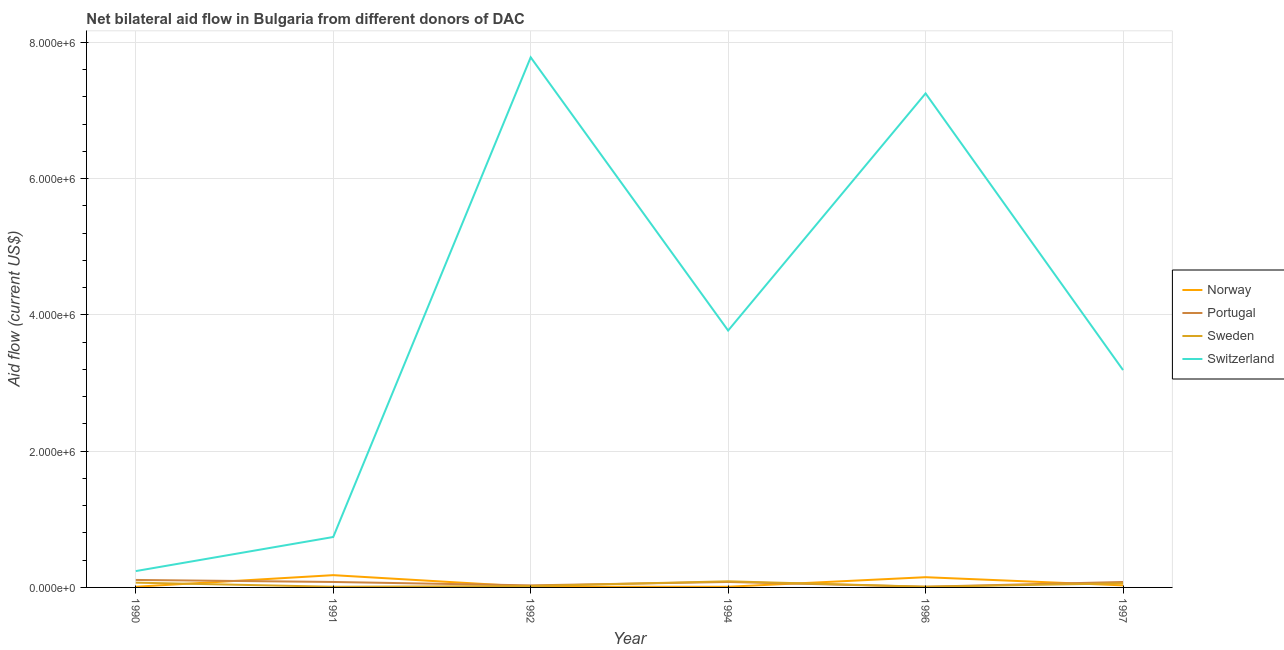Is the number of lines equal to the number of legend labels?
Offer a terse response. Yes. What is the amount of aid given by sweden in 1991?
Ensure brevity in your answer.  10000. Across all years, what is the maximum amount of aid given by sweden?
Provide a short and direct response. 9.00e+04. Across all years, what is the minimum amount of aid given by portugal?
Ensure brevity in your answer.  10000. In which year was the amount of aid given by switzerland maximum?
Give a very brief answer. 1992. What is the total amount of aid given by switzerland in the graph?
Provide a short and direct response. 2.30e+07. What is the difference between the amount of aid given by norway in 1991 and that in 1997?
Your answer should be very brief. 1.50e+05. What is the difference between the amount of aid given by switzerland in 1997 and the amount of aid given by norway in 1996?
Offer a very short reply. 3.04e+06. What is the average amount of aid given by sweden per year?
Your answer should be compact. 4.33e+04. In the year 1990, what is the difference between the amount of aid given by switzerland and amount of aid given by norway?
Your answer should be compact. 2.30e+05. Is the amount of aid given by switzerland in 1990 less than that in 1997?
Make the answer very short. Yes. What is the difference between the highest and the second highest amount of aid given by sweden?
Give a very brief answer. 2.00e+04. What is the difference between the highest and the lowest amount of aid given by norway?
Your response must be concise. 1.70e+05. In how many years, is the amount of aid given by norway greater than the average amount of aid given by norway taken over all years?
Offer a terse response. 2. Is the sum of the amount of aid given by switzerland in 1994 and 1996 greater than the maximum amount of aid given by sweden across all years?
Provide a succinct answer. Yes. Is it the case that in every year, the sum of the amount of aid given by switzerland and amount of aid given by portugal is greater than the sum of amount of aid given by sweden and amount of aid given by norway?
Provide a short and direct response. Yes. Does the amount of aid given by portugal monotonically increase over the years?
Make the answer very short. No. How many lines are there?
Give a very brief answer. 4. How many years are there in the graph?
Make the answer very short. 6. Are the values on the major ticks of Y-axis written in scientific E-notation?
Your answer should be compact. Yes. Where does the legend appear in the graph?
Keep it short and to the point. Center right. What is the title of the graph?
Offer a very short reply. Net bilateral aid flow in Bulgaria from different donors of DAC. Does "Quality of logistic services" appear as one of the legend labels in the graph?
Provide a short and direct response. No. What is the Aid flow (current US$) in Norway in 1990?
Give a very brief answer. 10000. What is the Aid flow (current US$) in Portugal in 1991?
Your response must be concise. 8.00e+04. What is the Aid flow (current US$) of Sweden in 1991?
Offer a terse response. 10000. What is the Aid flow (current US$) of Switzerland in 1991?
Your answer should be compact. 7.40e+05. What is the Aid flow (current US$) of Portugal in 1992?
Provide a short and direct response. 3.00e+04. What is the Aid flow (current US$) of Sweden in 1992?
Offer a very short reply. 2.00e+04. What is the Aid flow (current US$) in Switzerland in 1992?
Give a very brief answer. 7.78e+06. What is the Aid flow (current US$) in Portugal in 1994?
Offer a terse response. 8.00e+04. What is the Aid flow (current US$) of Switzerland in 1994?
Give a very brief answer. 3.77e+06. What is the Aid flow (current US$) of Norway in 1996?
Offer a terse response. 1.50e+05. What is the Aid flow (current US$) of Switzerland in 1996?
Your response must be concise. 7.25e+06. What is the Aid flow (current US$) in Sweden in 1997?
Provide a short and direct response. 6.00e+04. What is the Aid flow (current US$) of Switzerland in 1997?
Offer a terse response. 3.19e+06. Across all years, what is the maximum Aid flow (current US$) in Norway?
Keep it short and to the point. 1.80e+05. Across all years, what is the maximum Aid flow (current US$) in Switzerland?
Make the answer very short. 7.78e+06. Across all years, what is the minimum Aid flow (current US$) of Norway?
Ensure brevity in your answer.  10000. Across all years, what is the minimum Aid flow (current US$) of Sweden?
Ensure brevity in your answer.  10000. Across all years, what is the minimum Aid flow (current US$) in Switzerland?
Provide a short and direct response. 2.40e+05. What is the total Aid flow (current US$) in Sweden in the graph?
Ensure brevity in your answer.  2.60e+05. What is the total Aid flow (current US$) of Switzerland in the graph?
Ensure brevity in your answer.  2.30e+07. What is the difference between the Aid flow (current US$) of Switzerland in 1990 and that in 1991?
Make the answer very short. -5.00e+05. What is the difference between the Aid flow (current US$) of Norway in 1990 and that in 1992?
Give a very brief answer. 0. What is the difference between the Aid flow (current US$) in Portugal in 1990 and that in 1992?
Provide a succinct answer. 8.00e+04. What is the difference between the Aid flow (current US$) of Switzerland in 1990 and that in 1992?
Make the answer very short. -7.54e+06. What is the difference between the Aid flow (current US$) in Norway in 1990 and that in 1994?
Provide a succinct answer. 0. What is the difference between the Aid flow (current US$) of Sweden in 1990 and that in 1994?
Keep it short and to the point. -2.00e+04. What is the difference between the Aid flow (current US$) in Switzerland in 1990 and that in 1994?
Provide a succinct answer. -3.53e+06. What is the difference between the Aid flow (current US$) in Norway in 1990 and that in 1996?
Provide a short and direct response. -1.40e+05. What is the difference between the Aid flow (current US$) in Portugal in 1990 and that in 1996?
Provide a succinct answer. 1.00e+05. What is the difference between the Aid flow (current US$) of Switzerland in 1990 and that in 1996?
Keep it short and to the point. -7.01e+06. What is the difference between the Aid flow (current US$) of Switzerland in 1990 and that in 1997?
Provide a short and direct response. -2.95e+06. What is the difference between the Aid flow (current US$) of Portugal in 1991 and that in 1992?
Make the answer very short. 5.00e+04. What is the difference between the Aid flow (current US$) in Switzerland in 1991 and that in 1992?
Give a very brief answer. -7.04e+06. What is the difference between the Aid flow (current US$) in Switzerland in 1991 and that in 1994?
Offer a terse response. -3.03e+06. What is the difference between the Aid flow (current US$) in Sweden in 1991 and that in 1996?
Your answer should be compact. 0. What is the difference between the Aid flow (current US$) in Switzerland in 1991 and that in 1996?
Offer a terse response. -6.51e+06. What is the difference between the Aid flow (current US$) of Portugal in 1991 and that in 1997?
Ensure brevity in your answer.  0. What is the difference between the Aid flow (current US$) in Sweden in 1991 and that in 1997?
Provide a succinct answer. -5.00e+04. What is the difference between the Aid flow (current US$) of Switzerland in 1991 and that in 1997?
Provide a succinct answer. -2.45e+06. What is the difference between the Aid flow (current US$) in Sweden in 1992 and that in 1994?
Give a very brief answer. -7.00e+04. What is the difference between the Aid flow (current US$) in Switzerland in 1992 and that in 1994?
Give a very brief answer. 4.01e+06. What is the difference between the Aid flow (current US$) of Portugal in 1992 and that in 1996?
Your answer should be compact. 2.00e+04. What is the difference between the Aid flow (current US$) of Switzerland in 1992 and that in 1996?
Your answer should be compact. 5.30e+05. What is the difference between the Aid flow (current US$) in Norway in 1992 and that in 1997?
Provide a succinct answer. -2.00e+04. What is the difference between the Aid flow (current US$) in Switzerland in 1992 and that in 1997?
Provide a succinct answer. 4.59e+06. What is the difference between the Aid flow (current US$) of Norway in 1994 and that in 1996?
Offer a very short reply. -1.40e+05. What is the difference between the Aid flow (current US$) in Switzerland in 1994 and that in 1996?
Ensure brevity in your answer.  -3.48e+06. What is the difference between the Aid flow (current US$) in Switzerland in 1994 and that in 1997?
Your response must be concise. 5.80e+05. What is the difference between the Aid flow (current US$) in Portugal in 1996 and that in 1997?
Offer a very short reply. -7.00e+04. What is the difference between the Aid flow (current US$) in Sweden in 1996 and that in 1997?
Offer a very short reply. -5.00e+04. What is the difference between the Aid flow (current US$) of Switzerland in 1996 and that in 1997?
Offer a terse response. 4.06e+06. What is the difference between the Aid flow (current US$) of Norway in 1990 and the Aid flow (current US$) of Switzerland in 1991?
Your response must be concise. -7.30e+05. What is the difference between the Aid flow (current US$) of Portugal in 1990 and the Aid flow (current US$) of Sweden in 1991?
Your response must be concise. 1.00e+05. What is the difference between the Aid flow (current US$) in Portugal in 1990 and the Aid flow (current US$) in Switzerland in 1991?
Provide a succinct answer. -6.30e+05. What is the difference between the Aid flow (current US$) in Sweden in 1990 and the Aid flow (current US$) in Switzerland in 1991?
Ensure brevity in your answer.  -6.70e+05. What is the difference between the Aid flow (current US$) in Norway in 1990 and the Aid flow (current US$) in Sweden in 1992?
Provide a succinct answer. -10000. What is the difference between the Aid flow (current US$) in Norway in 1990 and the Aid flow (current US$) in Switzerland in 1992?
Give a very brief answer. -7.77e+06. What is the difference between the Aid flow (current US$) in Portugal in 1990 and the Aid flow (current US$) in Sweden in 1992?
Your answer should be compact. 9.00e+04. What is the difference between the Aid flow (current US$) of Portugal in 1990 and the Aid flow (current US$) of Switzerland in 1992?
Make the answer very short. -7.67e+06. What is the difference between the Aid flow (current US$) in Sweden in 1990 and the Aid flow (current US$) in Switzerland in 1992?
Your answer should be very brief. -7.71e+06. What is the difference between the Aid flow (current US$) of Norway in 1990 and the Aid flow (current US$) of Portugal in 1994?
Offer a very short reply. -7.00e+04. What is the difference between the Aid flow (current US$) in Norway in 1990 and the Aid flow (current US$) in Switzerland in 1994?
Give a very brief answer. -3.76e+06. What is the difference between the Aid flow (current US$) in Portugal in 1990 and the Aid flow (current US$) in Switzerland in 1994?
Your answer should be very brief. -3.66e+06. What is the difference between the Aid flow (current US$) of Sweden in 1990 and the Aid flow (current US$) of Switzerland in 1994?
Your response must be concise. -3.70e+06. What is the difference between the Aid flow (current US$) of Norway in 1990 and the Aid flow (current US$) of Switzerland in 1996?
Your answer should be very brief. -7.24e+06. What is the difference between the Aid flow (current US$) in Portugal in 1990 and the Aid flow (current US$) in Switzerland in 1996?
Make the answer very short. -7.14e+06. What is the difference between the Aid flow (current US$) in Sweden in 1990 and the Aid flow (current US$) in Switzerland in 1996?
Offer a terse response. -7.18e+06. What is the difference between the Aid flow (current US$) in Norway in 1990 and the Aid flow (current US$) in Portugal in 1997?
Your answer should be compact. -7.00e+04. What is the difference between the Aid flow (current US$) of Norway in 1990 and the Aid flow (current US$) of Switzerland in 1997?
Make the answer very short. -3.18e+06. What is the difference between the Aid flow (current US$) in Portugal in 1990 and the Aid flow (current US$) in Switzerland in 1997?
Make the answer very short. -3.08e+06. What is the difference between the Aid flow (current US$) of Sweden in 1990 and the Aid flow (current US$) of Switzerland in 1997?
Your answer should be compact. -3.12e+06. What is the difference between the Aid flow (current US$) of Norway in 1991 and the Aid flow (current US$) of Switzerland in 1992?
Provide a succinct answer. -7.60e+06. What is the difference between the Aid flow (current US$) of Portugal in 1991 and the Aid flow (current US$) of Sweden in 1992?
Provide a succinct answer. 6.00e+04. What is the difference between the Aid flow (current US$) in Portugal in 1991 and the Aid flow (current US$) in Switzerland in 1992?
Your answer should be compact. -7.70e+06. What is the difference between the Aid flow (current US$) in Sweden in 1991 and the Aid flow (current US$) in Switzerland in 1992?
Your answer should be very brief. -7.77e+06. What is the difference between the Aid flow (current US$) of Norway in 1991 and the Aid flow (current US$) of Portugal in 1994?
Ensure brevity in your answer.  1.00e+05. What is the difference between the Aid flow (current US$) of Norway in 1991 and the Aid flow (current US$) of Switzerland in 1994?
Your answer should be compact. -3.59e+06. What is the difference between the Aid flow (current US$) in Portugal in 1991 and the Aid flow (current US$) in Sweden in 1994?
Your answer should be very brief. -10000. What is the difference between the Aid flow (current US$) of Portugal in 1991 and the Aid flow (current US$) of Switzerland in 1994?
Make the answer very short. -3.69e+06. What is the difference between the Aid flow (current US$) of Sweden in 1991 and the Aid flow (current US$) of Switzerland in 1994?
Provide a succinct answer. -3.76e+06. What is the difference between the Aid flow (current US$) of Norway in 1991 and the Aid flow (current US$) of Portugal in 1996?
Ensure brevity in your answer.  1.70e+05. What is the difference between the Aid flow (current US$) in Norway in 1991 and the Aid flow (current US$) in Switzerland in 1996?
Provide a succinct answer. -7.07e+06. What is the difference between the Aid flow (current US$) of Portugal in 1991 and the Aid flow (current US$) of Switzerland in 1996?
Offer a very short reply. -7.17e+06. What is the difference between the Aid flow (current US$) of Sweden in 1991 and the Aid flow (current US$) of Switzerland in 1996?
Offer a very short reply. -7.24e+06. What is the difference between the Aid flow (current US$) in Norway in 1991 and the Aid flow (current US$) in Portugal in 1997?
Your answer should be compact. 1.00e+05. What is the difference between the Aid flow (current US$) of Norway in 1991 and the Aid flow (current US$) of Switzerland in 1997?
Keep it short and to the point. -3.01e+06. What is the difference between the Aid flow (current US$) in Portugal in 1991 and the Aid flow (current US$) in Sweden in 1997?
Offer a terse response. 2.00e+04. What is the difference between the Aid flow (current US$) of Portugal in 1991 and the Aid flow (current US$) of Switzerland in 1997?
Your response must be concise. -3.11e+06. What is the difference between the Aid flow (current US$) of Sweden in 1991 and the Aid flow (current US$) of Switzerland in 1997?
Keep it short and to the point. -3.18e+06. What is the difference between the Aid flow (current US$) in Norway in 1992 and the Aid flow (current US$) in Sweden in 1994?
Provide a succinct answer. -8.00e+04. What is the difference between the Aid flow (current US$) in Norway in 1992 and the Aid flow (current US$) in Switzerland in 1994?
Ensure brevity in your answer.  -3.76e+06. What is the difference between the Aid flow (current US$) of Portugal in 1992 and the Aid flow (current US$) of Switzerland in 1994?
Provide a short and direct response. -3.74e+06. What is the difference between the Aid flow (current US$) of Sweden in 1992 and the Aid flow (current US$) of Switzerland in 1994?
Make the answer very short. -3.75e+06. What is the difference between the Aid flow (current US$) of Norway in 1992 and the Aid flow (current US$) of Portugal in 1996?
Offer a terse response. 0. What is the difference between the Aid flow (current US$) of Norway in 1992 and the Aid flow (current US$) of Switzerland in 1996?
Ensure brevity in your answer.  -7.24e+06. What is the difference between the Aid flow (current US$) in Portugal in 1992 and the Aid flow (current US$) in Switzerland in 1996?
Provide a short and direct response. -7.22e+06. What is the difference between the Aid flow (current US$) of Sweden in 1992 and the Aid flow (current US$) of Switzerland in 1996?
Provide a short and direct response. -7.23e+06. What is the difference between the Aid flow (current US$) of Norway in 1992 and the Aid flow (current US$) of Portugal in 1997?
Make the answer very short. -7.00e+04. What is the difference between the Aid flow (current US$) in Norway in 1992 and the Aid flow (current US$) in Sweden in 1997?
Make the answer very short. -5.00e+04. What is the difference between the Aid flow (current US$) of Norway in 1992 and the Aid flow (current US$) of Switzerland in 1997?
Give a very brief answer. -3.18e+06. What is the difference between the Aid flow (current US$) in Portugal in 1992 and the Aid flow (current US$) in Sweden in 1997?
Provide a succinct answer. -3.00e+04. What is the difference between the Aid flow (current US$) in Portugal in 1992 and the Aid flow (current US$) in Switzerland in 1997?
Provide a short and direct response. -3.16e+06. What is the difference between the Aid flow (current US$) in Sweden in 1992 and the Aid flow (current US$) in Switzerland in 1997?
Ensure brevity in your answer.  -3.17e+06. What is the difference between the Aid flow (current US$) in Norway in 1994 and the Aid flow (current US$) in Portugal in 1996?
Provide a succinct answer. 0. What is the difference between the Aid flow (current US$) of Norway in 1994 and the Aid flow (current US$) of Sweden in 1996?
Offer a terse response. 0. What is the difference between the Aid flow (current US$) in Norway in 1994 and the Aid flow (current US$) in Switzerland in 1996?
Provide a succinct answer. -7.24e+06. What is the difference between the Aid flow (current US$) in Portugal in 1994 and the Aid flow (current US$) in Switzerland in 1996?
Offer a terse response. -7.17e+06. What is the difference between the Aid flow (current US$) in Sweden in 1994 and the Aid flow (current US$) in Switzerland in 1996?
Make the answer very short. -7.16e+06. What is the difference between the Aid flow (current US$) of Norway in 1994 and the Aid flow (current US$) of Sweden in 1997?
Make the answer very short. -5.00e+04. What is the difference between the Aid flow (current US$) of Norway in 1994 and the Aid flow (current US$) of Switzerland in 1997?
Offer a very short reply. -3.18e+06. What is the difference between the Aid flow (current US$) of Portugal in 1994 and the Aid flow (current US$) of Switzerland in 1997?
Offer a terse response. -3.11e+06. What is the difference between the Aid flow (current US$) of Sweden in 1994 and the Aid flow (current US$) of Switzerland in 1997?
Give a very brief answer. -3.10e+06. What is the difference between the Aid flow (current US$) in Norway in 1996 and the Aid flow (current US$) in Portugal in 1997?
Your answer should be compact. 7.00e+04. What is the difference between the Aid flow (current US$) in Norway in 1996 and the Aid flow (current US$) in Switzerland in 1997?
Make the answer very short. -3.04e+06. What is the difference between the Aid flow (current US$) in Portugal in 1996 and the Aid flow (current US$) in Sweden in 1997?
Your answer should be very brief. -5.00e+04. What is the difference between the Aid flow (current US$) of Portugal in 1996 and the Aid flow (current US$) of Switzerland in 1997?
Ensure brevity in your answer.  -3.18e+06. What is the difference between the Aid flow (current US$) of Sweden in 1996 and the Aid flow (current US$) of Switzerland in 1997?
Make the answer very short. -3.18e+06. What is the average Aid flow (current US$) in Norway per year?
Ensure brevity in your answer.  6.50e+04. What is the average Aid flow (current US$) of Portugal per year?
Ensure brevity in your answer.  6.50e+04. What is the average Aid flow (current US$) in Sweden per year?
Ensure brevity in your answer.  4.33e+04. What is the average Aid flow (current US$) of Switzerland per year?
Your response must be concise. 3.83e+06. In the year 1990, what is the difference between the Aid flow (current US$) of Norway and Aid flow (current US$) of Portugal?
Your answer should be compact. -1.00e+05. In the year 1990, what is the difference between the Aid flow (current US$) of Norway and Aid flow (current US$) of Sweden?
Ensure brevity in your answer.  -6.00e+04. In the year 1990, what is the difference between the Aid flow (current US$) in Portugal and Aid flow (current US$) in Switzerland?
Offer a very short reply. -1.30e+05. In the year 1990, what is the difference between the Aid flow (current US$) in Sweden and Aid flow (current US$) in Switzerland?
Provide a short and direct response. -1.70e+05. In the year 1991, what is the difference between the Aid flow (current US$) in Norway and Aid flow (current US$) in Switzerland?
Make the answer very short. -5.60e+05. In the year 1991, what is the difference between the Aid flow (current US$) of Portugal and Aid flow (current US$) of Sweden?
Your response must be concise. 7.00e+04. In the year 1991, what is the difference between the Aid flow (current US$) in Portugal and Aid flow (current US$) in Switzerland?
Offer a terse response. -6.60e+05. In the year 1991, what is the difference between the Aid flow (current US$) of Sweden and Aid flow (current US$) of Switzerland?
Give a very brief answer. -7.30e+05. In the year 1992, what is the difference between the Aid flow (current US$) of Norway and Aid flow (current US$) of Sweden?
Provide a short and direct response. -10000. In the year 1992, what is the difference between the Aid flow (current US$) of Norway and Aid flow (current US$) of Switzerland?
Give a very brief answer. -7.77e+06. In the year 1992, what is the difference between the Aid flow (current US$) of Portugal and Aid flow (current US$) of Switzerland?
Offer a terse response. -7.75e+06. In the year 1992, what is the difference between the Aid flow (current US$) in Sweden and Aid flow (current US$) in Switzerland?
Give a very brief answer. -7.76e+06. In the year 1994, what is the difference between the Aid flow (current US$) in Norway and Aid flow (current US$) in Sweden?
Provide a short and direct response. -8.00e+04. In the year 1994, what is the difference between the Aid flow (current US$) of Norway and Aid flow (current US$) of Switzerland?
Your answer should be compact. -3.76e+06. In the year 1994, what is the difference between the Aid flow (current US$) of Portugal and Aid flow (current US$) of Switzerland?
Provide a succinct answer. -3.69e+06. In the year 1994, what is the difference between the Aid flow (current US$) in Sweden and Aid flow (current US$) in Switzerland?
Your answer should be very brief. -3.68e+06. In the year 1996, what is the difference between the Aid flow (current US$) of Norway and Aid flow (current US$) of Portugal?
Provide a succinct answer. 1.40e+05. In the year 1996, what is the difference between the Aid flow (current US$) in Norway and Aid flow (current US$) in Switzerland?
Ensure brevity in your answer.  -7.10e+06. In the year 1996, what is the difference between the Aid flow (current US$) in Portugal and Aid flow (current US$) in Sweden?
Offer a terse response. 0. In the year 1996, what is the difference between the Aid flow (current US$) in Portugal and Aid flow (current US$) in Switzerland?
Your answer should be compact. -7.24e+06. In the year 1996, what is the difference between the Aid flow (current US$) in Sweden and Aid flow (current US$) in Switzerland?
Provide a short and direct response. -7.24e+06. In the year 1997, what is the difference between the Aid flow (current US$) in Norway and Aid flow (current US$) in Portugal?
Ensure brevity in your answer.  -5.00e+04. In the year 1997, what is the difference between the Aid flow (current US$) of Norway and Aid flow (current US$) of Switzerland?
Ensure brevity in your answer.  -3.16e+06. In the year 1997, what is the difference between the Aid flow (current US$) in Portugal and Aid flow (current US$) in Sweden?
Your answer should be compact. 2.00e+04. In the year 1997, what is the difference between the Aid flow (current US$) in Portugal and Aid flow (current US$) in Switzerland?
Make the answer very short. -3.11e+06. In the year 1997, what is the difference between the Aid flow (current US$) of Sweden and Aid flow (current US$) of Switzerland?
Offer a very short reply. -3.13e+06. What is the ratio of the Aid flow (current US$) in Norway in 1990 to that in 1991?
Your answer should be compact. 0.06. What is the ratio of the Aid flow (current US$) of Portugal in 1990 to that in 1991?
Provide a succinct answer. 1.38. What is the ratio of the Aid flow (current US$) in Switzerland in 1990 to that in 1991?
Make the answer very short. 0.32. What is the ratio of the Aid flow (current US$) in Portugal in 1990 to that in 1992?
Give a very brief answer. 3.67. What is the ratio of the Aid flow (current US$) in Sweden in 1990 to that in 1992?
Ensure brevity in your answer.  3.5. What is the ratio of the Aid flow (current US$) in Switzerland in 1990 to that in 1992?
Your response must be concise. 0.03. What is the ratio of the Aid flow (current US$) of Portugal in 1990 to that in 1994?
Ensure brevity in your answer.  1.38. What is the ratio of the Aid flow (current US$) of Switzerland in 1990 to that in 1994?
Your response must be concise. 0.06. What is the ratio of the Aid flow (current US$) of Norway in 1990 to that in 1996?
Offer a very short reply. 0.07. What is the ratio of the Aid flow (current US$) in Portugal in 1990 to that in 1996?
Your answer should be very brief. 11. What is the ratio of the Aid flow (current US$) in Sweden in 1990 to that in 1996?
Provide a succinct answer. 7. What is the ratio of the Aid flow (current US$) of Switzerland in 1990 to that in 1996?
Offer a terse response. 0.03. What is the ratio of the Aid flow (current US$) of Portugal in 1990 to that in 1997?
Provide a succinct answer. 1.38. What is the ratio of the Aid flow (current US$) in Switzerland in 1990 to that in 1997?
Offer a very short reply. 0.08. What is the ratio of the Aid flow (current US$) in Portugal in 1991 to that in 1992?
Give a very brief answer. 2.67. What is the ratio of the Aid flow (current US$) in Sweden in 1991 to that in 1992?
Your answer should be compact. 0.5. What is the ratio of the Aid flow (current US$) in Switzerland in 1991 to that in 1992?
Offer a very short reply. 0.1. What is the ratio of the Aid flow (current US$) of Portugal in 1991 to that in 1994?
Your answer should be very brief. 1. What is the ratio of the Aid flow (current US$) in Sweden in 1991 to that in 1994?
Offer a terse response. 0.11. What is the ratio of the Aid flow (current US$) in Switzerland in 1991 to that in 1994?
Provide a short and direct response. 0.2. What is the ratio of the Aid flow (current US$) in Norway in 1991 to that in 1996?
Give a very brief answer. 1.2. What is the ratio of the Aid flow (current US$) in Portugal in 1991 to that in 1996?
Offer a terse response. 8. What is the ratio of the Aid flow (current US$) in Sweden in 1991 to that in 1996?
Give a very brief answer. 1. What is the ratio of the Aid flow (current US$) in Switzerland in 1991 to that in 1996?
Ensure brevity in your answer.  0.1. What is the ratio of the Aid flow (current US$) of Switzerland in 1991 to that in 1997?
Provide a succinct answer. 0.23. What is the ratio of the Aid flow (current US$) of Portugal in 1992 to that in 1994?
Offer a very short reply. 0.38. What is the ratio of the Aid flow (current US$) of Sweden in 1992 to that in 1994?
Offer a very short reply. 0.22. What is the ratio of the Aid flow (current US$) in Switzerland in 1992 to that in 1994?
Ensure brevity in your answer.  2.06. What is the ratio of the Aid flow (current US$) in Norway in 1992 to that in 1996?
Offer a very short reply. 0.07. What is the ratio of the Aid flow (current US$) of Portugal in 1992 to that in 1996?
Give a very brief answer. 3. What is the ratio of the Aid flow (current US$) of Switzerland in 1992 to that in 1996?
Your answer should be very brief. 1.07. What is the ratio of the Aid flow (current US$) in Switzerland in 1992 to that in 1997?
Your response must be concise. 2.44. What is the ratio of the Aid flow (current US$) in Norway in 1994 to that in 1996?
Make the answer very short. 0.07. What is the ratio of the Aid flow (current US$) in Switzerland in 1994 to that in 1996?
Make the answer very short. 0.52. What is the ratio of the Aid flow (current US$) in Norway in 1994 to that in 1997?
Keep it short and to the point. 0.33. What is the ratio of the Aid flow (current US$) of Portugal in 1994 to that in 1997?
Provide a succinct answer. 1. What is the ratio of the Aid flow (current US$) of Switzerland in 1994 to that in 1997?
Your answer should be compact. 1.18. What is the ratio of the Aid flow (current US$) in Norway in 1996 to that in 1997?
Give a very brief answer. 5. What is the ratio of the Aid flow (current US$) in Portugal in 1996 to that in 1997?
Your answer should be compact. 0.12. What is the ratio of the Aid flow (current US$) in Switzerland in 1996 to that in 1997?
Your answer should be compact. 2.27. What is the difference between the highest and the second highest Aid flow (current US$) of Sweden?
Your response must be concise. 2.00e+04. What is the difference between the highest and the second highest Aid flow (current US$) of Switzerland?
Give a very brief answer. 5.30e+05. What is the difference between the highest and the lowest Aid flow (current US$) of Norway?
Keep it short and to the point. 1.70e+05. What is the difference between the highest and the lowest Aid flow (current US$) of Portugal?
Make the answer very short. 1.00e+05. What is the difference between the highest and the lowest Aid flow (current US$) of Switzerland?
Provide a succinct answer. 7.54e+06. 